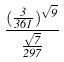Convert formula to latex. <formula><loc_0><loc_0><loc_500><loc_500>\frac { ( \frac { 3 } { 3 6 1 } ) ^ { \sqrt { 9 } } } { \frac { \sqrt { 7 } } { 2 9 7 } }</formula> 